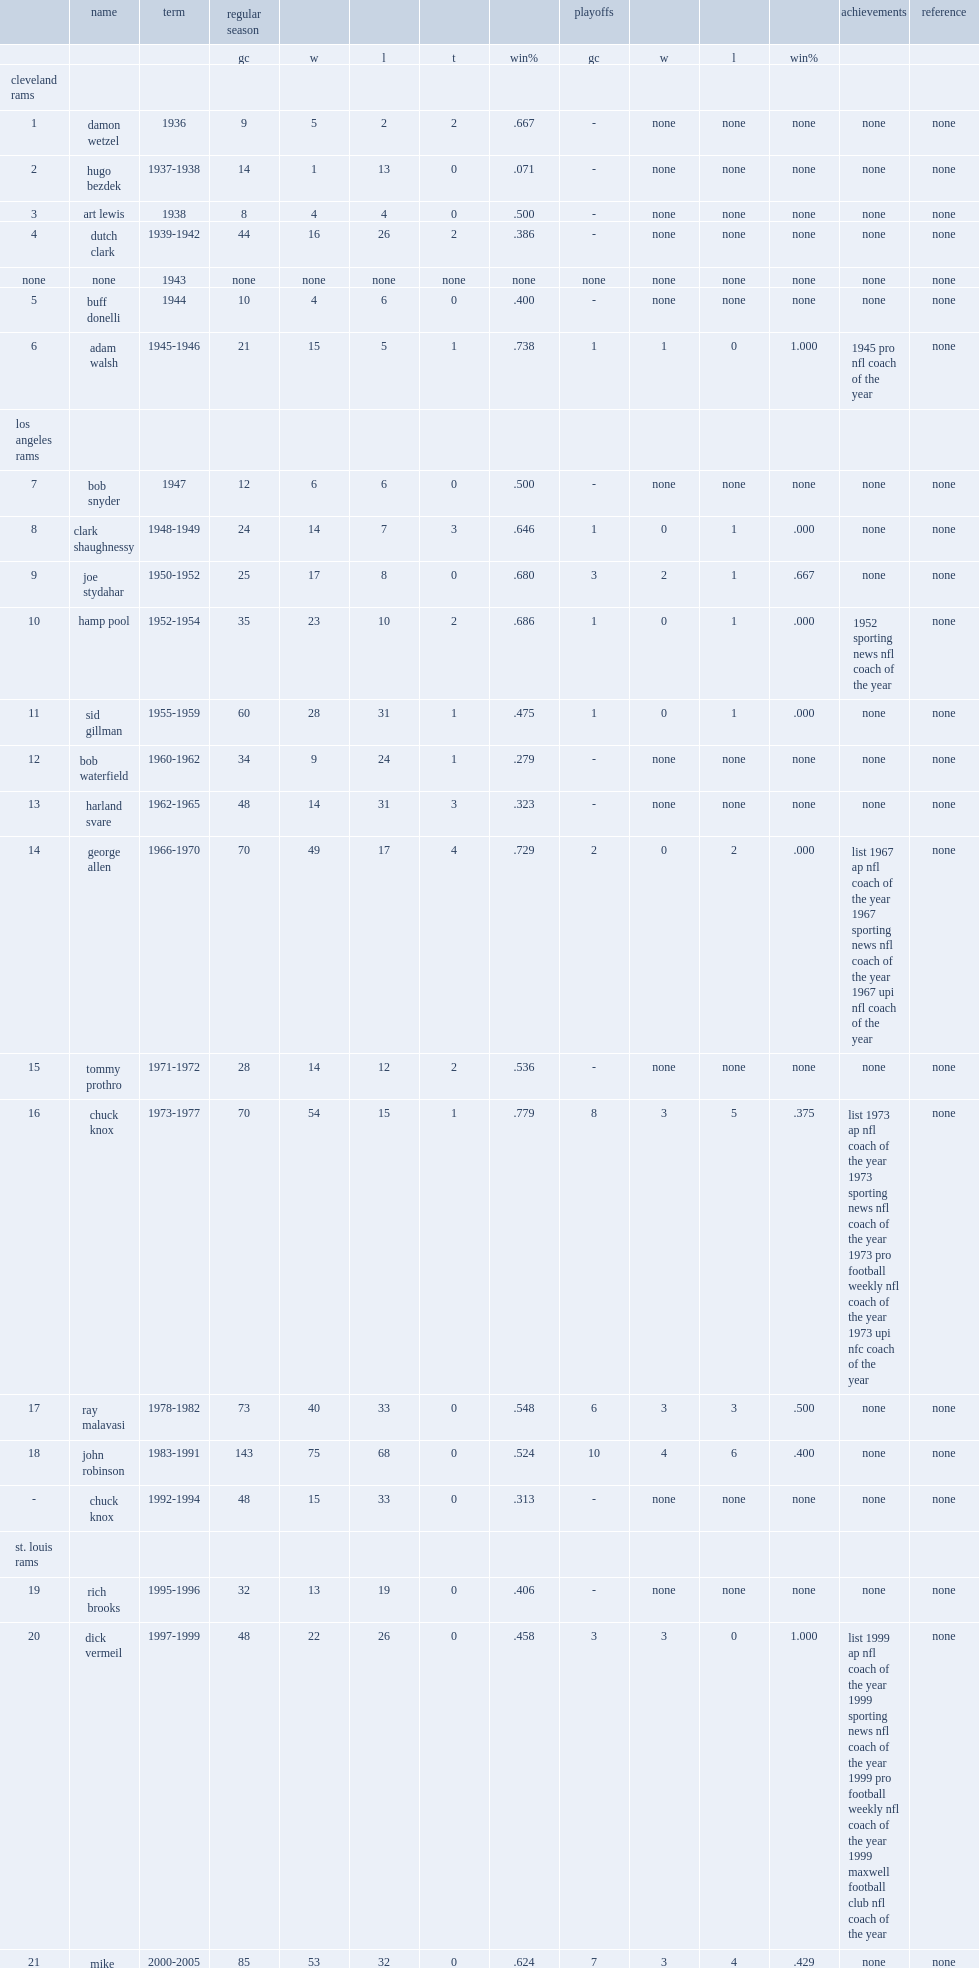Who was the head coach of los angeles rams in 2017. Sean mcvay. 